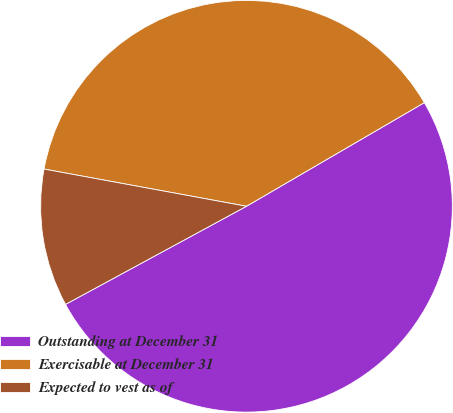<chart> <loc_0><loc_0><loc_500><loc_500><pie_chart><fcel>Outstanding at December 31<fcel>Exercisable at December 31<fcel>Expected to vest as of<nl><fcel>50.49%<fcel>38.71%<fcel>10.8%<nl></chart> 